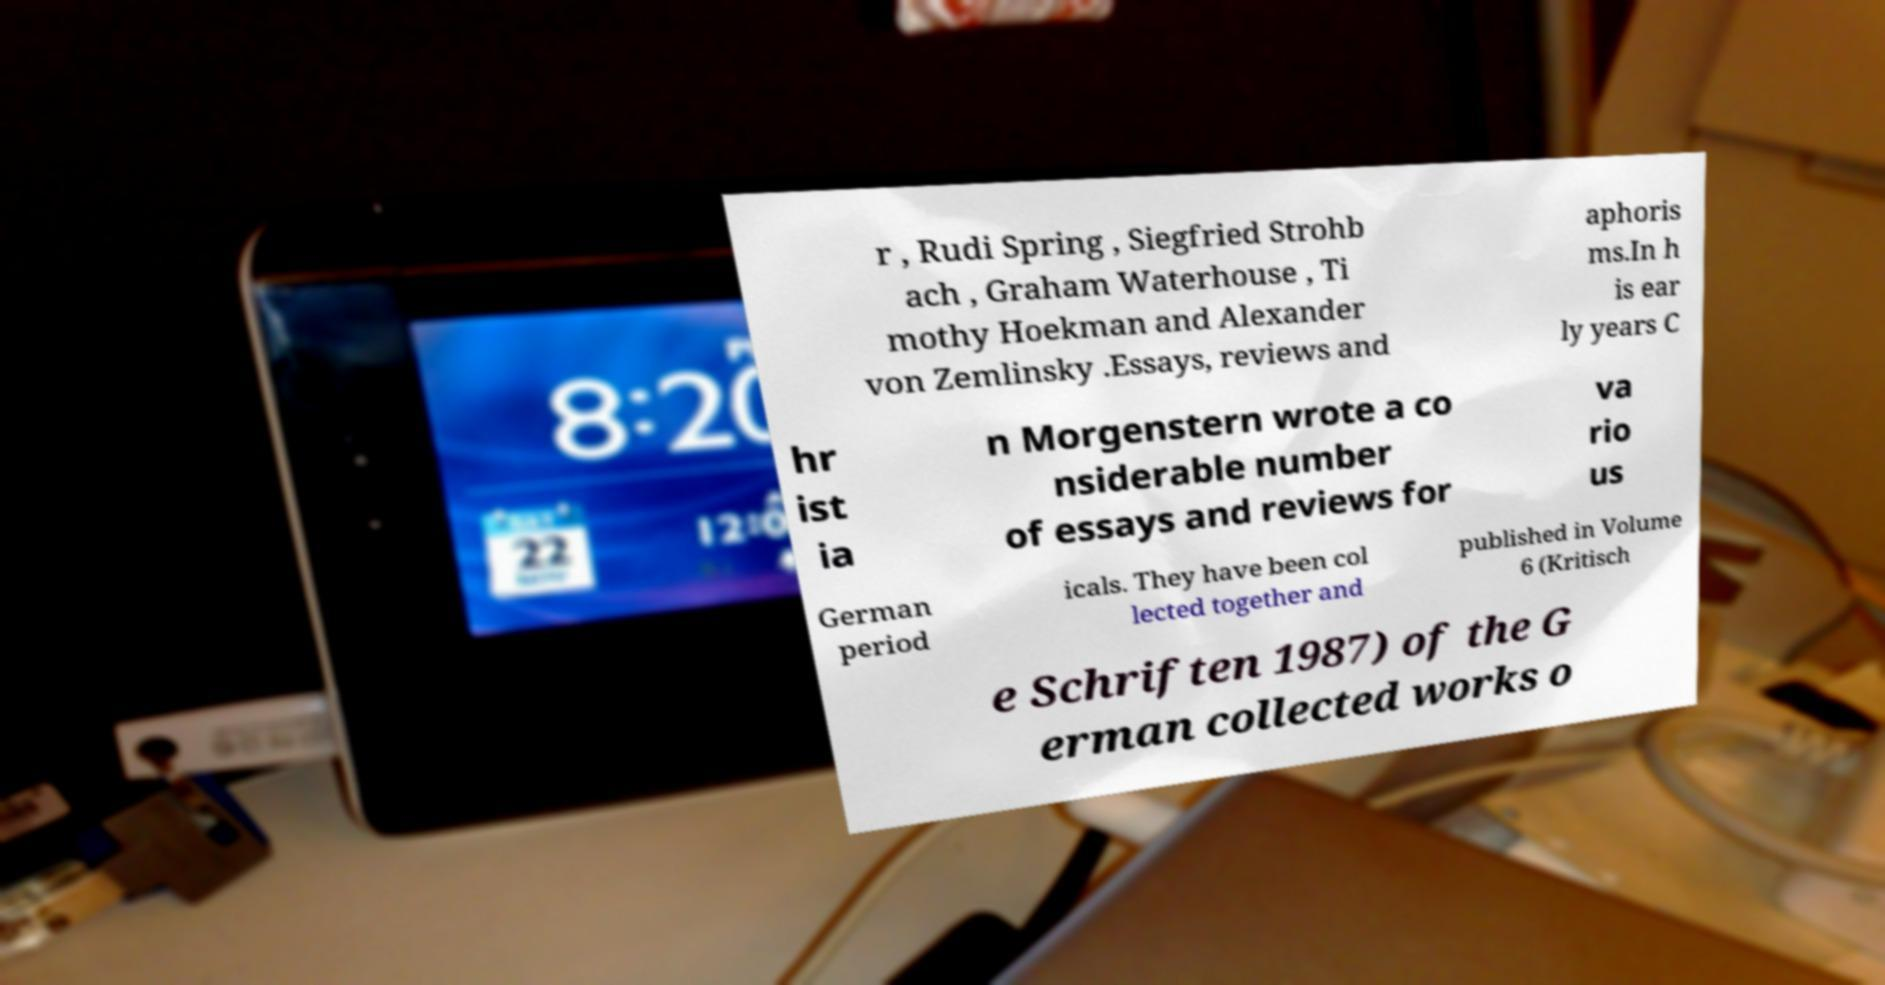For documentation purposes, I need the text within this image transcribed. Could you provide that? r , Rudi Spring , Siegfried Strohb ach , Graham Waterhouse , Ti mothy Hoekman and Alexander von Zemlinsky .Essays, reviews and aphoris ms.In h is ear ly years C hr ist ia n Morgenstern wrote a co nsiderable number of essays and reviews for va rio us German period icals. They have been col lected together and published in Volume 6 (Kritisch e Schriften 1987) of the G erman collected works o 